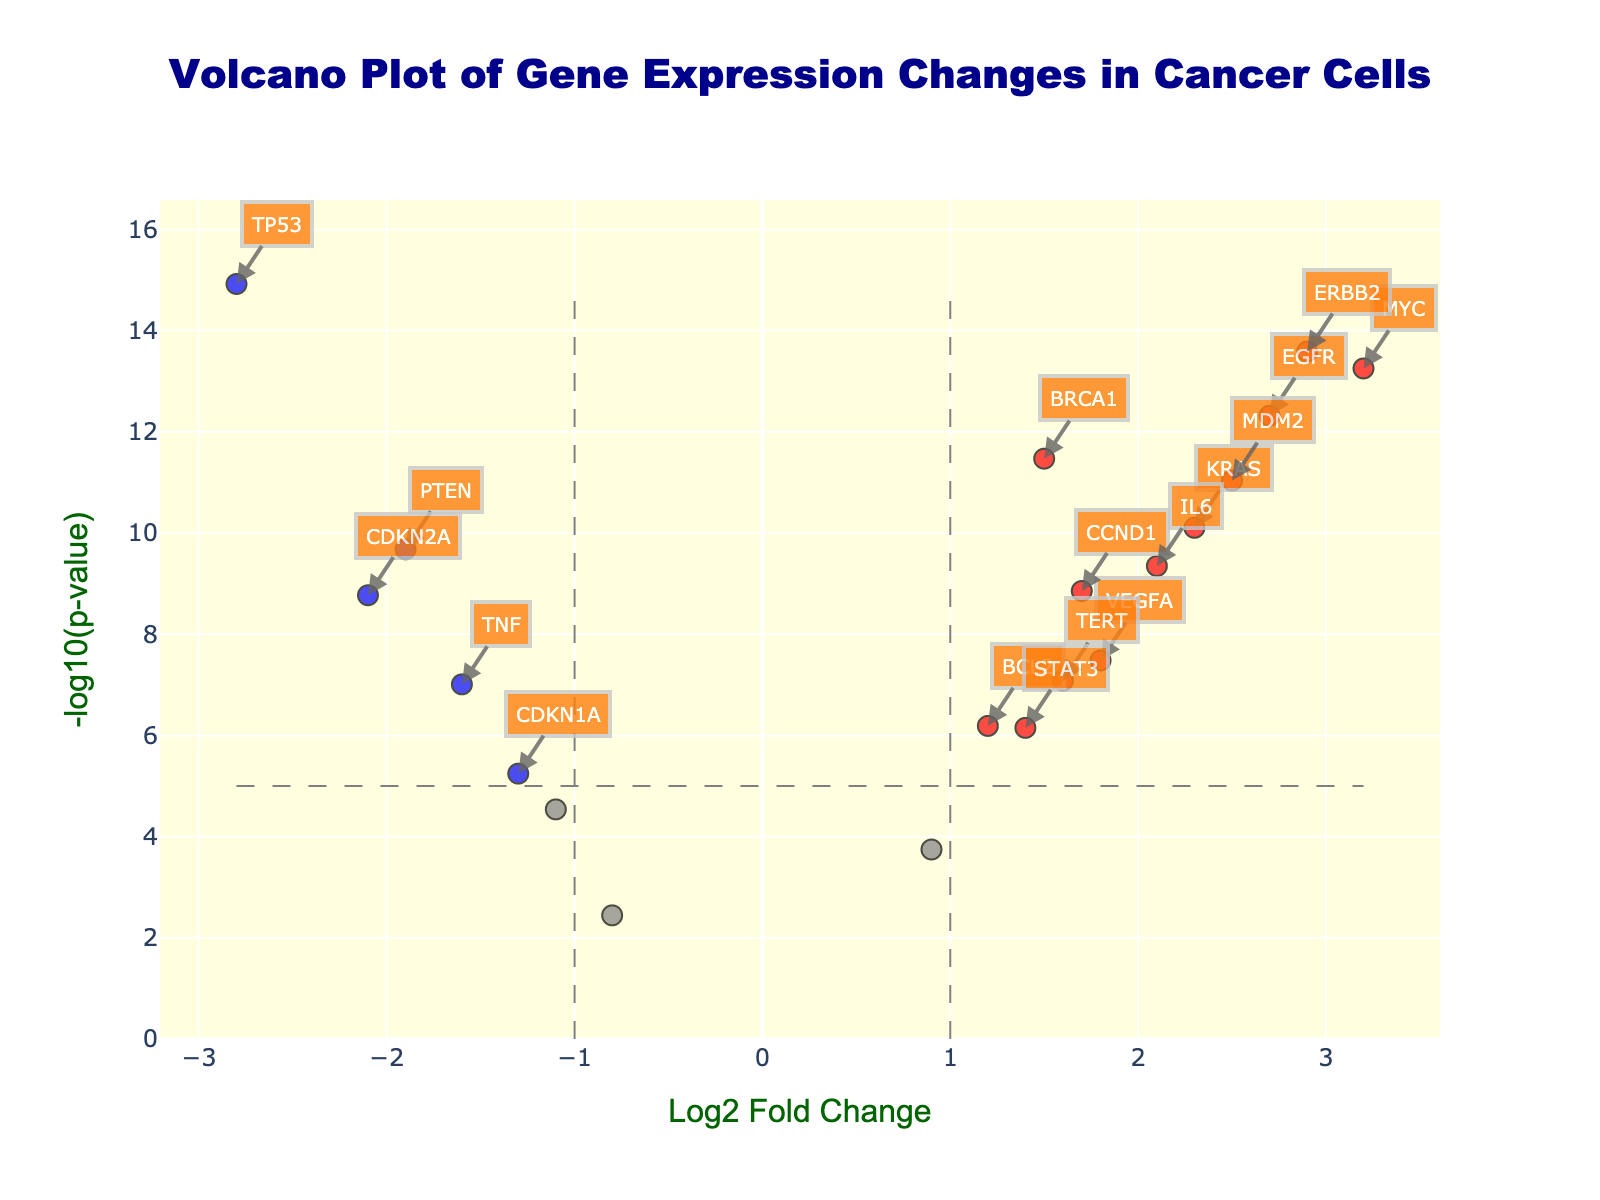What is the title of the volcano plot? The title of the volcano plot is displayed at the top of the figure and reads "Volcano Plot of Gene Expression Changes in Cancer Cells".
Answer: Volcano Plot of Gene Expression Changes in Cancer Cells What does the y-axis represent in this plot? The y-axis in this plot represents the -log10(p-value), which is a common way to visualize the significance level of each gene's expression change.
Answer: -log10(p-value) How many genes are significantly up-regulated? To determine the number of significantly up-regulated genes, we look at the points colored in red, which represent genes with a log2 fold change greater than 1 and a -log10(p-value) greater than 5. There are 8 such points.
Answer: 8 Which gene has the highest log2 fold change? We identify the gene by finding the point with the maximum x-value on the plot, which is 3.2. The gene with the highest log2 fold change is MYC.
Answer: MYC Compare the significance of the genes TP53 and MYC. Which one is more significant? To compare significance, we look at the -log10(p-value) of both genes. TP53 has a -log10(p-value) around 15, while MYC has a -log10(p-value) around 14. Thus, TP53 is more significant.
Answer: TP53 How many genes are down-regulated with a log2 fold change less than -1? To find the number of down-regulated genes with a log2 fold change less than -1, we count the blue points, which meet the criteria. There are 5 such points.
Answer: 5 Between the genes BRCA1 and PTEN, which has a lower p-value? By comparing the -log10(p-value) values, BRCA1 has a -log10(p-value) that is slightly above 12, whereas PTEN has a -log10(p-value) below 10. Hence, BRCA1 has a lower p-value.
Answer: BRCA1 Which gene is the least significant among the up-regulated genes? Among the up-regulated genes (red points), VEGFA has the lowest -log10(p-value), just above 7.
Answer: VEGFA What is the log2 fold change of the gene KRAS? The log2 fold change can be visually identified as the x-coordinates of the KRAS label. The log2 fold change of KRAS is 2.3.
Answer: 2.3 How are significantly down-regulated genes represented on the plot? Significantly down-regulated genes have a log2 fold change less than -1 and -log10(p-value) greater than 5, and are colored in blue on the plot.
Answer: blue 